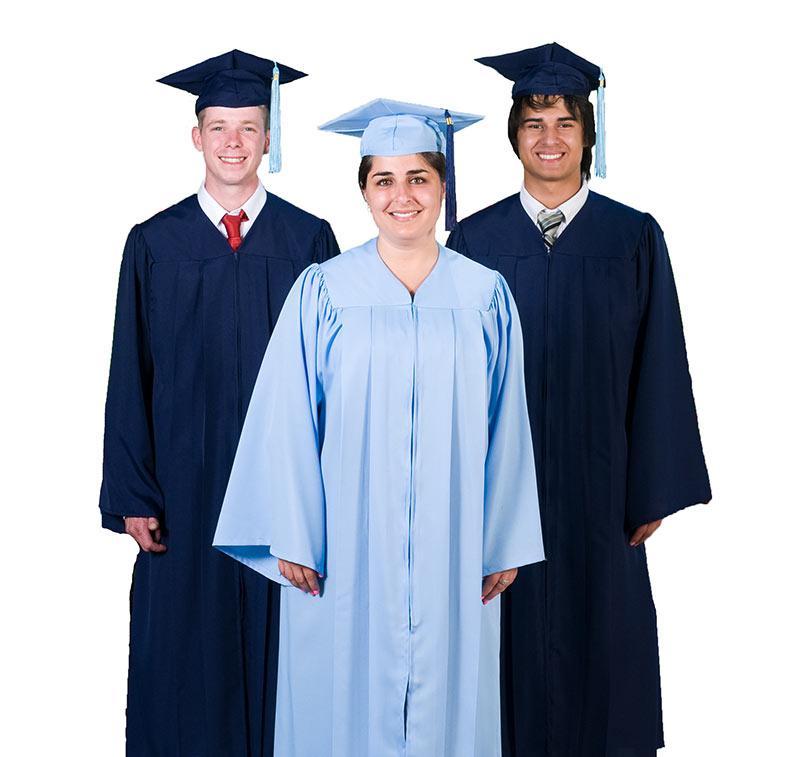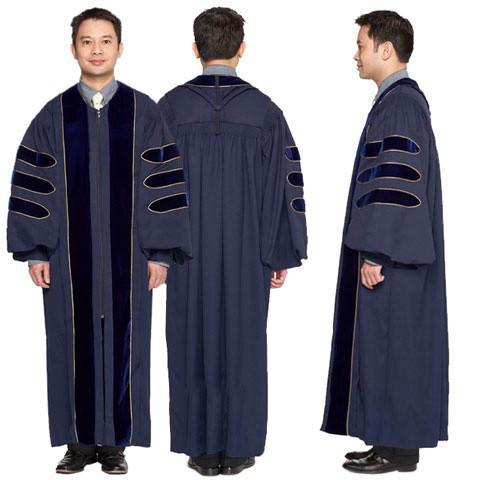The first image is the image on the left, the second image is the image on the right. Considering the images on both sides, is "In one image, a graduation gown model is wearing silver high heeled shoes." valid? Answer yes or no. No. The first image is the image on the left, the second image is the image on the right. For the images displayed, is the sentence "One out of four graduates has her back turned towards the camera." factually correct? Answer yes or no. No. 